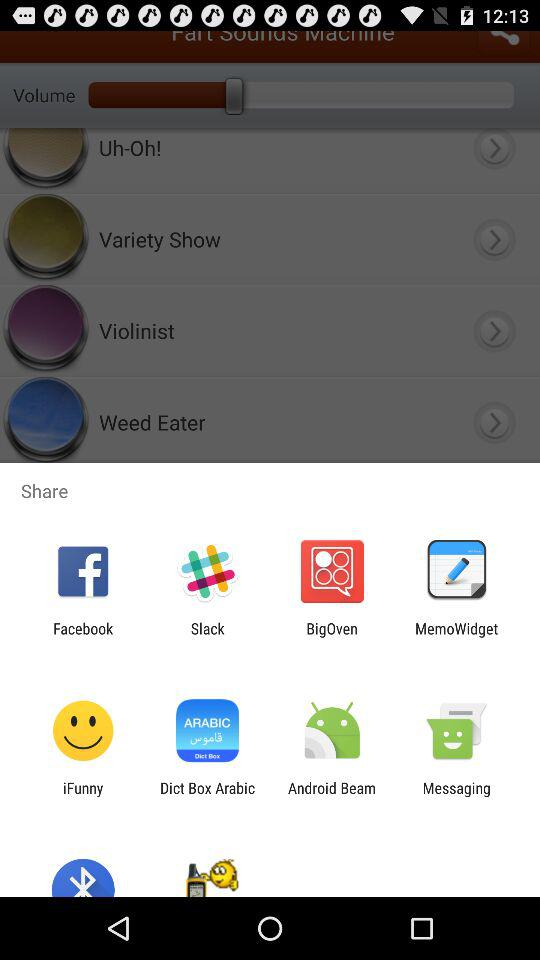Which application can be used to share? The applications that can be used to share are "Facebook", "Slack", "BigOven", "MemoWidget", "iFunny", "Dict Box Arabic", "Android Beam" and "Messaging". 